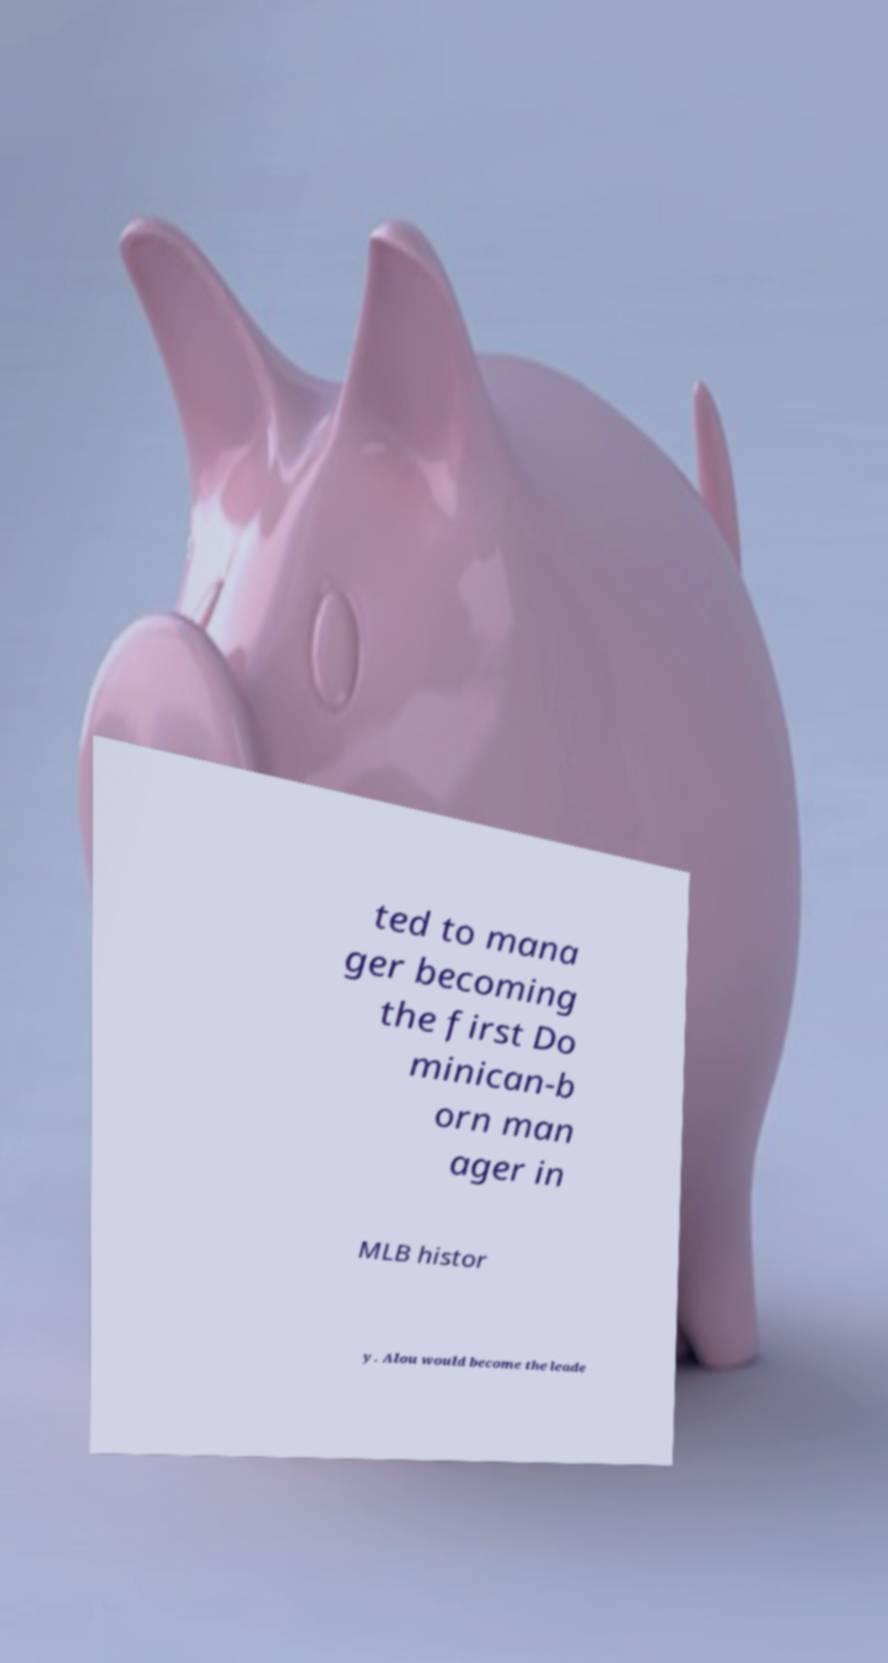There's text embedded in this image that I need extracted. Can you transcribe it verbatim? ted to mana ger becoming the first Do minican-b orn man ager in MLB histor y. Alou would become the leade 